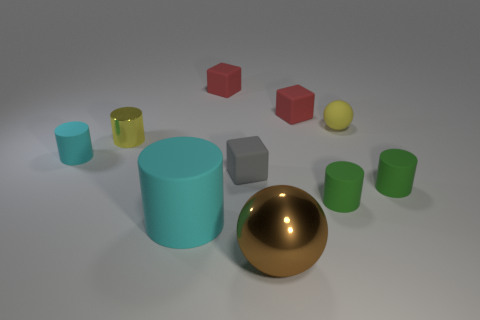There is a big thing left of the small gray matte object; is its shape the same as the yellow matte thing?
Ensure brevity in your answer.  No. Is the number of brown balls that are behind the rubber ball greater than the number of cyan matte cylinders behind the small yellow shiny object?
Give a very brief answer. No. There is a rubber block that is on the left side of the gray cube; what number of tiny yellow balls are to the left of it?
Your response must be concise. 0. What is the material of the tiny thing that is the same color as the tiny metal cylinder?
Give a very brief answer. Rubber. What number of other objects are the same color as the tiny metallic thing?
Provide a short and direct response. 1. What color is the ball that is to the left of the small yellow thing right of the metal sphere?
Offer a very short reply. Brown. Are there any small cylinders of the same color as the matte sphere?
Your response must be concise. Yes. How many metallic things are gray things or small balls?
Offer a very short reply. 0. Are there any balls that have the same material as the tiny yellow cylinder?
Your answer should be compact. Yes. How many matte cylinders are to the right of the shiny ball and on the left side of the tiny yellow metal object?
Give a very brief answer. 0. 